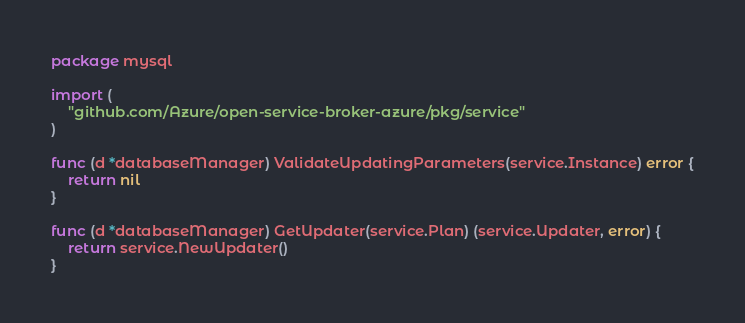<code> <loc_0><loc_0><loc_500><loc_500><_Go_>package mysql

import (
	"github.com/Azure/open-service-broker-azure/pkg/service"
)

func (d *databaseManager) ValidateUpdatingParameters(service.Instance) error {
	return nil
}

func (d *databaseManager) GetUpdater(service.Plan) (service.Updater, error) {
	return service.NewUpdater()
}
</code> 